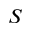<formula> <loc_0><loc_0><loc_500><loc_500>S</formula> 